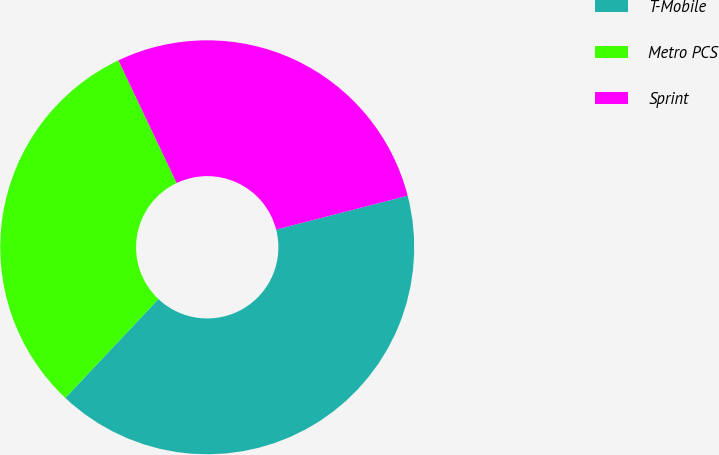Convert chart. <chart><loc_0><loc_0><loc_500><loc_500><pie_chart><fcel>T-Mobile<fcel>Metro PCS<fcel>Sprint<nl><fcel>41.04%<fcel>30.91%<fcel>28.05%<nl></chart> 